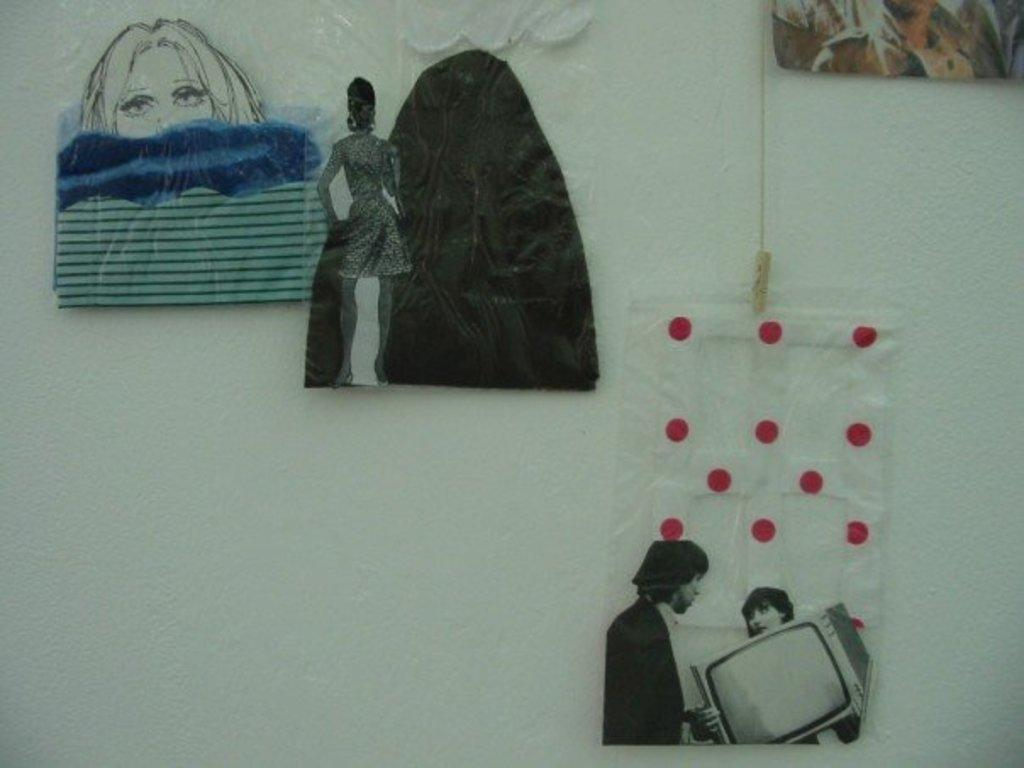What is the color of the wall in the image? The wall in the image is white. What can be seen on the wall in the image? There are decorative items on the wall in the image. What type of quill is being used to write on the wall in the image? There is no quill or writing present on the wall in the image. How many dolls are sitting on the white wall in the image? There are no dolls present in the image. 